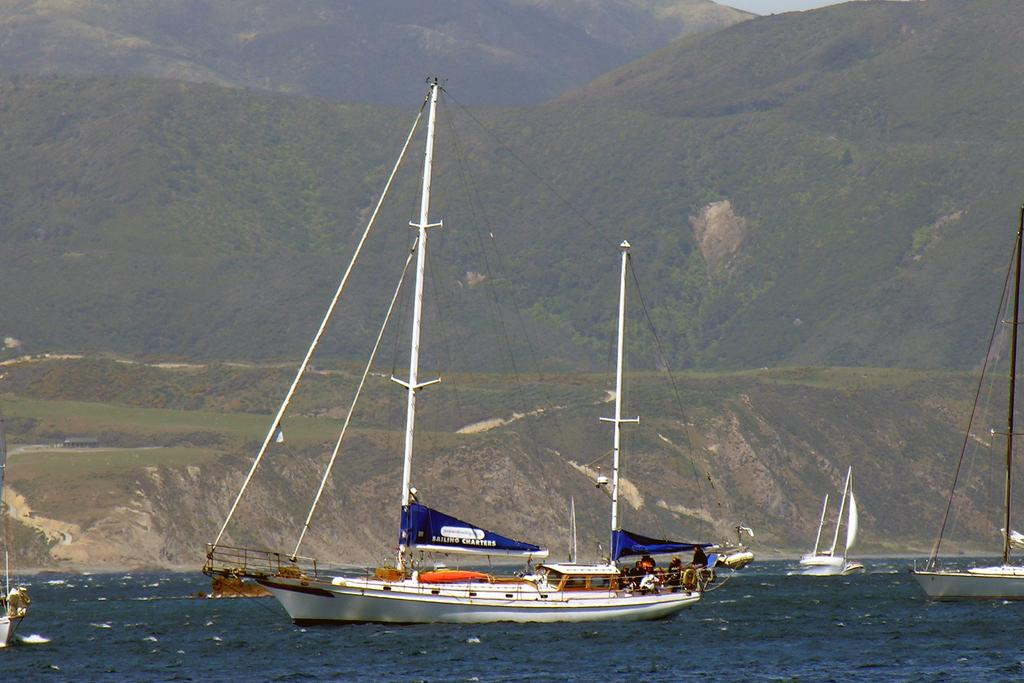What is on the water in the image? There are boats on the water in the image. What objects can be seen in the image besides the boats? There are poles and flags in the image. Who or what is present in the image? There are people in the image. What can be seen in the background of the image? There are trees, mountains, and the sky visible in the background of the image. What type of sand can be seen on the beach in the image? There is no beach or sand present in the image; it features boats on the water, poles, flags, people, trees, mountains, and the sky in the background. What punishment is being given to the trees in the image? There is no punishment being given to the trees in the image; they are simply part of the background landscape. 